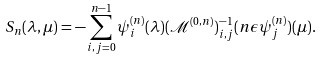Convert formula to latex. <formula><loc_0><loc_0><loc_500><loc_500>S _ { n } ( \lambda , \mu ) = - \sum _ { i , j = 0 } ^ { n - 1 } \psi ^ { ( n ) } _ { i } ( \lambda ) ( \mathcal { M } ^ { ( 0 , n ) } ) ^ { - 1 } _ { i , j } ( n \epsilon \psi ^ { ( n ) } _ { j } ) ( \mu ) .</formula> 